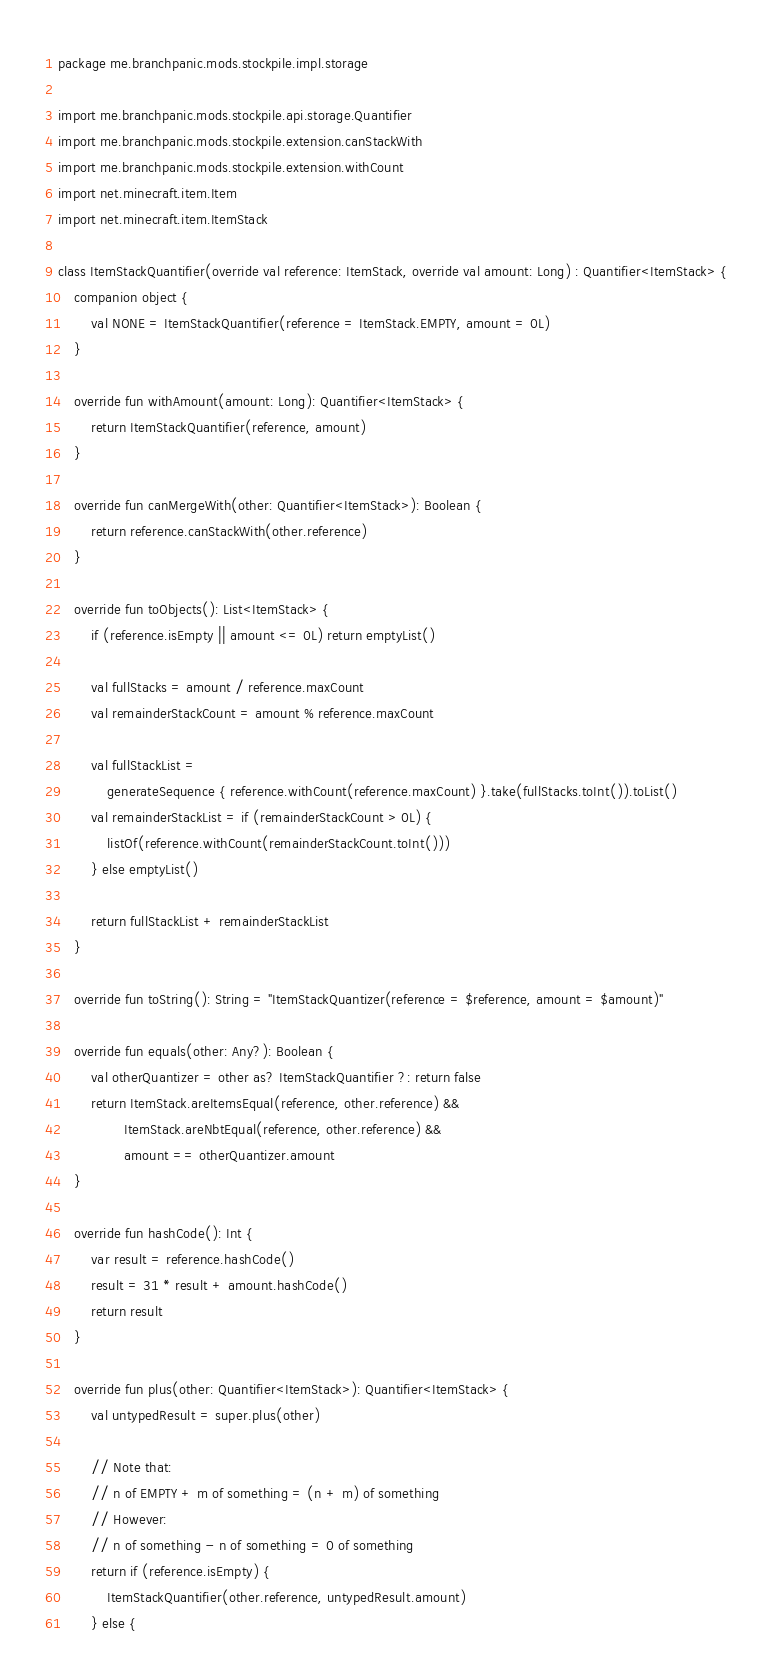Convert code to text. <code><loc_0><loc_0><loc_500><loc_500><_Kotlin_>package me.branchpanic.mods.stockpile.impl.storage

import me.branchpanic.mods.stockpile.api.storage.Quantifier
import me.branchpanic.mods.stockpile.extension.canStackWith
import me.branchpanic.mods.stockpile.extension.withCount
import net.minecraft.item.Item
import net.minecraft.item.ItemStack

class ItemStackQuantifier(override val reference: ItemStack, override val amount: Long) : Quantifier<ItemStack> {
    companion object {
        val NONE = ItemStackQuantifier(reference = ItemStack.EMPTY, amount = 0L)
    }

    override fun withAmount(amount: Long): Quantifier<ItemStack> {
        return ItemStackQuantifier(reference, amount)
    }

    override fun canMergeWith(other: Quantifier<ItemStack>): Boolean {
        return reference.canStackWith(other.reference)
    }

    override fun toObjects(): List<ItemStack> {
        if (reference.isEmpty || amount <= 0L) return emptyList()

        val fullStacks = amount / reference.maxCount
        val remainderStackCount = amount % reference.maxCount

        val fullStackList =
            generateSequence { reference.withCount(reference.maxCount) }.take(fullStacks.toInt()).toList()
        val remainderStackList = if (remainderStackCount > 0L) {
            listOf(reference.withCount(remainderStackCount.toInt()))
        } else emptyList()

        return fullStackList + remainderStackList
    }

    override fun toString(): String = "ItemStackQuantizer(reference = $reference, amount = $amount)"

    override fun equals(other: Any?): Boolean {
        val otherQuantizer = other as? ItemStackQuantifier ?: return false
        return ItemStack.areItemsEqual(reference, other.reference) &&
                ItemStack.areNbtEqual(reference, other.reference) &&
                amount == otherQuantizer.amount
    }

    override fun hashCode(): Int {
        var result = reference.hashCode()
        result = 31 * result + amount.hashCode()
        return result
    }

    override fun plus(other: Quantifier<ItemStack>): Quantifier<ItemStack> {
        val untypedResult = super.plus(other)

        // Note that:
        // n of EMPTY + m of something = (n + m) of something
        // However:
        // n of something - n of something = 0 of something
        return if (reference.isEmpty) {
            ItemStackQuantifier(other.reference, untypedResult.amount)
        } else {</code> 